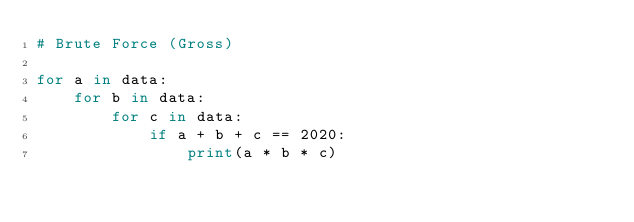<code> <loc_0><loc_0><loc_500><loc_500><_Python_># Brute Force (Gross)

for a in data:
    for b in data:
        for c in data:
            if a + b + c == 2020:
                print(a * b * c)

</code> 